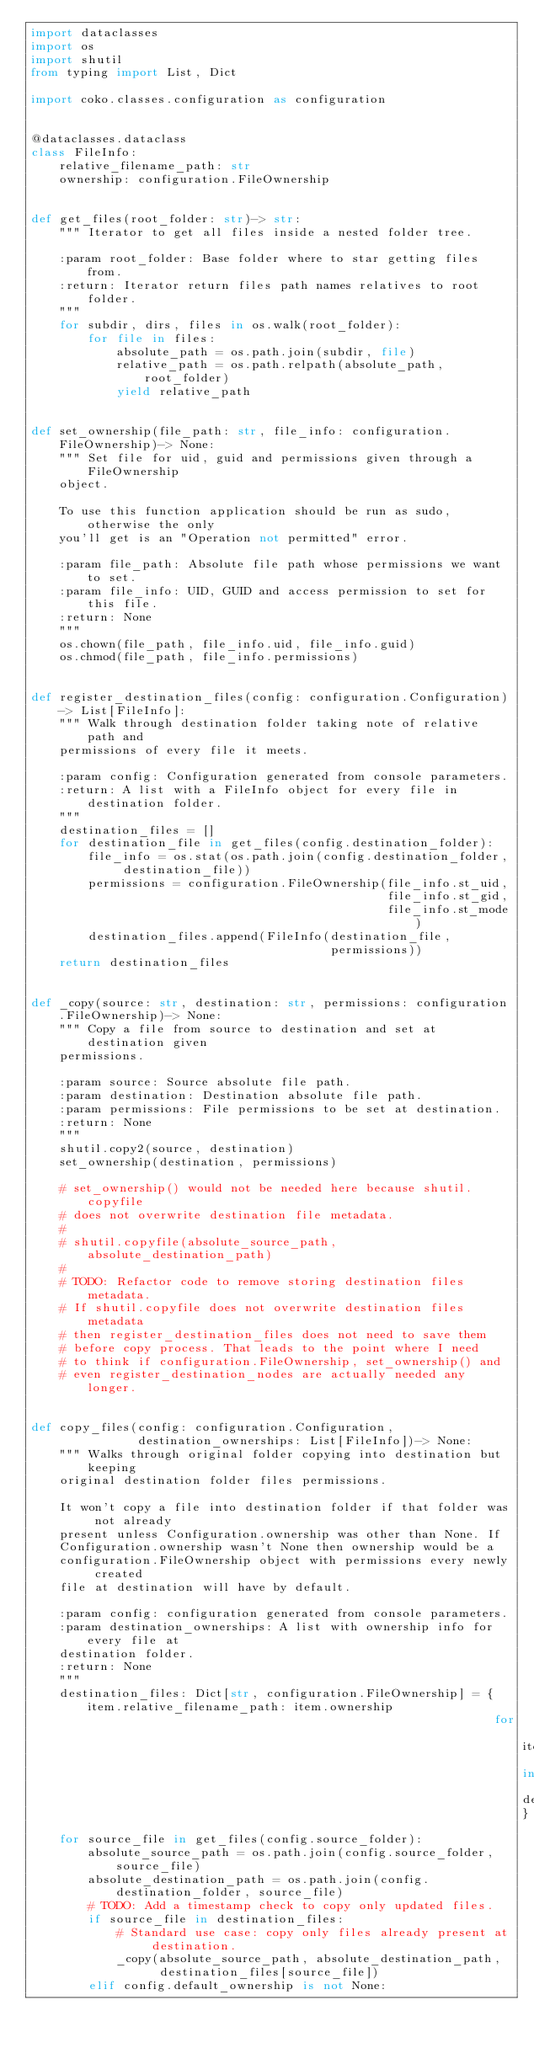Convert code to text. <code><loc_0><loc_0><loc_500><loc_500><_Python_>import dataclasses
import os
import shutil
from typing import List, Dict

import coko.classes.configuration as configuration


@dataclasses.dataclass
class FileInfo:
    relative_filename_path: str
    ownership: configuration.FileOwnership


def get_files(root_folder: str)-> str:
    """ Iterator to get all files inside a nested folder tree.

    :param root_folder: Base folder where to star getting files from.
    :return: Iterator return files path names relatives to root folder.
    """
    for subdir, dirs, files in os.walk(root_folder):
        for file in files:
            absolute_path = os.path.join(subdir, file)
            relative_path = os.path.relpath(absolute_path, root_folder)
            yield relative_path


def set_ownership(file_path: str, file_info: configuration.FileOwnership)-> None:
    """ Set file for uid, guid and permissions given through a FileOwnership
    object.

    To use this function application should be run as sudo, otherwise the only
    you'll get is an "Operation not permitted" error.

    :param file_path: Absolute file path whose permissions we want to set.
    :param file_info: UID, GUID and access permission to set for this file.
    :return: None
    """
    os.chown(file_path, file_info.uid, file_info.guid)
    os.chmod(file_path, file_info.permissions)


def register_destination_files(config: configuration.Configuration)-> List[FileInfo]:
    """ Walk through destination folder taking note of relative path and
    permissions of every file it meets.

    :param config: Configuration generated from console parameters.
    :return: A list with a FileInfo object for every file in destination folder.
    """
    destination_files = []
    for destination_file in get_files(config.destination_folder):
        file_info = os.stat(os.path.join(config.destination_folder, destination_file))
        permissions = configuration.FileOwnership(file_info.st_uid,
                                                  file_info.st_gid,
                                                  file_info.st_mode)
        destination_files.append(FileInfo(destination_file,
                                          permissions))
    return destination_files


def _copy(source: str, destination: str, permissions: configuration.FileOwnership)-> None:
    """ Copy a file from source to destination and set at destination given
    permissions.

    :param source: Source absolute file path.
    :param destination: Destination absolute file path.
    :param permissions: File permissions to be set at destination.
    :return: None
    """
    shutil.copy2(source, destination)
    set_ownership(destination, permissions)

    # set_ownership() would not be needed here because shutil.copyfile
    # does not overwrite destination file metadata.
    #
    # shutil.copyfile(absolute_source_path, absolute_destination_path)
    #
    # TODO: Refactor code to remove storing destination files metadata.
    # If shutil.copyfile does not overwrite destination files metadata
    # then register_destination_files does not need to save them
    # before copy process. That leads to the point where I need
    # to think if configuration.FileOwnership, set_ownership() and
    # even register_destination_nodes are actually needed any longer.


def copy_files(config: configuration.Configuration,
               destination_ownerships: List[FileInfo])-> None:
    """ Walks through original folder copying into destination but keeping
    original destination folder files permissions.

    It won't copy a file into destination folder if that folder was not already
    present unless Configuration.ownership was other than None. If
    Configuration.ownership wasn't None then ownership would be a
    configuration.FileOwnership object with permissions every newly created
    file at destination will have by default.

    :param config: configuration generated from console parameters.
    :param destination_ownerships: A list with ownership info for every file at
    destination folder.
    :return: None
    """
    destination_files: Dict[str, configuration.FileOwnership] = {item.relative_filename_path: item.ownership
                                                                 for item in destination_ownerships}
    for source_file in get_files(config.source_folder):
        absolute_source_path = os.path.join(config.source_folder, source_file)
        absolute_destination_path = os.path.join(config.destination_folder, source_file)
        # TODO: Add a timestamp check to copy only updated files.
        if source_file in destination_files:
            # Standard use case: copy only files already present at destination.
            _copy(absolute_source_path, absolute_destination_path,
                  destination_files[source_file])
        elif config.default_ownership is not None:</code> 